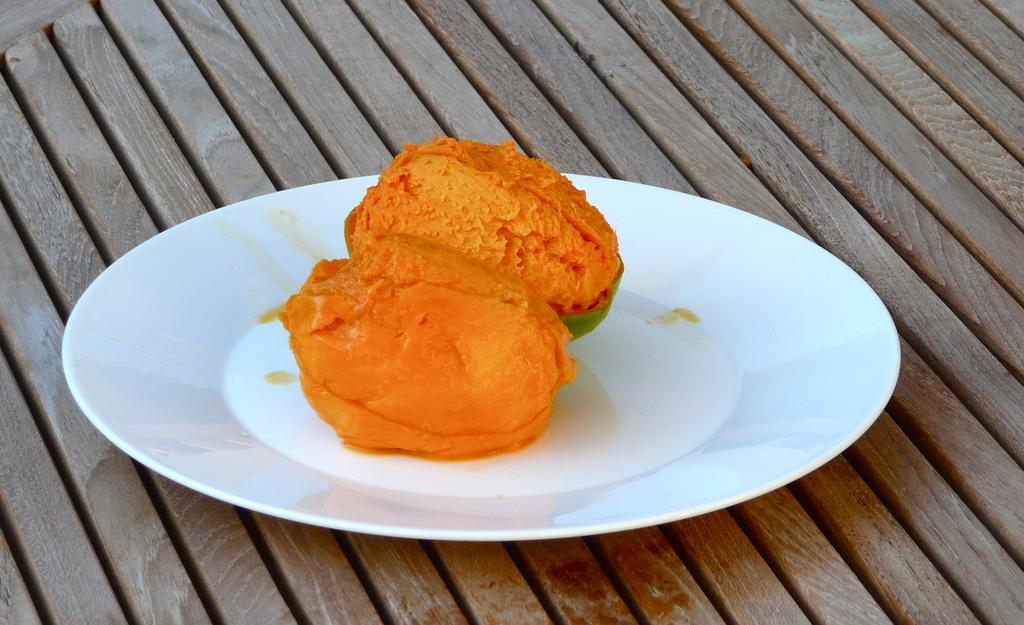Could you give a brief overview of what you see in this image? In this image we can see a plate containing fruits placed on the table. 